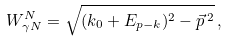<formula> <loc_0><loc_0><loc_500><loc_500>W _ { \gamma N } ^ { N } = \sqrt { ( k _ { 0 } + E _ { p - k } ) ^ { 2 } - \vec { p } \, ^ { 2 } } \, ,</formula> 